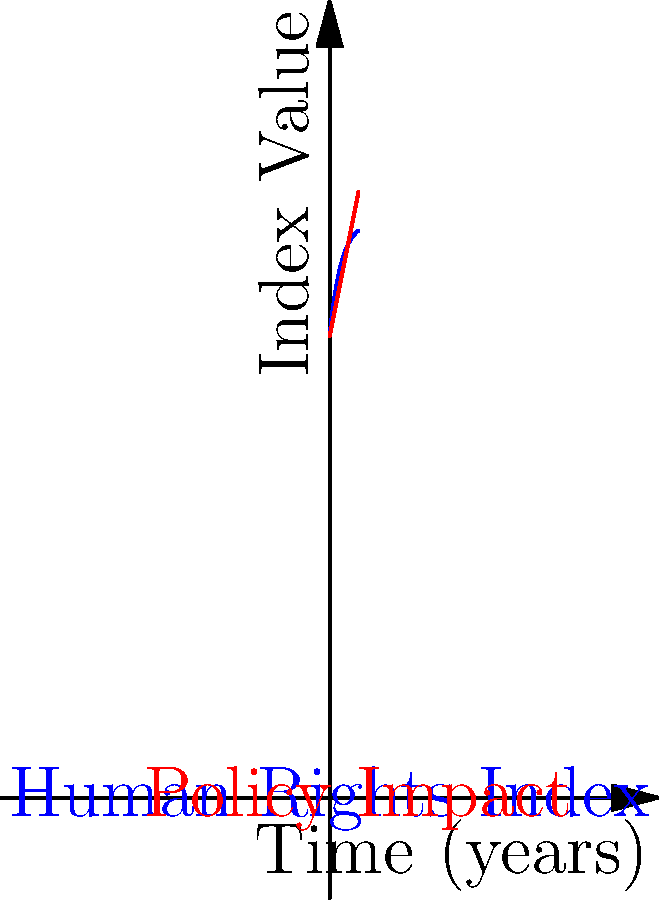Consider the graph above, where the blue curve represents the Human Rights Index (HRI) over time, given by the function $f(t) = 100 - 20e^{-0.5t}$, and the red line represents the cumulative impact of policy changes on human rights, given by $g(t) = 80 + 5t$. Calculate the total difference between the Human Rights Index and the policy impact over the first 5 years, represented by the area between the two curves from $t=0$ to $t=5$.

$$\int_0^5 [f(t) - g(t)] dt$$ To solve this integral calculus problem, we'll follow these steps:

1) First, let's set up the integral:
   $$\int_0^5 [(100 - 20e^{-0.5t}) - (80 + 5t)] dt$$

2) Simplify the integrand:
   $$\int_0^5 [20 - 20e^{-0.5t} - 5t] dt$$

3) Now, we can split this into three integrals:
   $$\int_0^5 20 dt - \int_0^5 20e^{-0.5t} dt - \int_0^5 5t dt$$

4) Solve each integral:
   a) $\int_0^5 20 dt = 20t |_0^5 = 100$
   
   b) $\int_0^5 20e^{-0.5t} dt = -40e^{-0.5t} |_0^5 = -40(e^{-2.5} - 1)$
   
   c) $\int_0^5 5t dt = \frac{5t^2}{2} |_0^5 = \frac{125}{2}$

5) Combine the results:
   $100 - [-40(e^{-2.5} - 1)] - \frac{125}{2}$

6) Simplify:
   $100 + 40(e^{-2.5} - 1) - 62.5$
   $= 37.5 + 40(e^{-2.5} - 1)$
   $≈ 22.95$ (rounded to two decimal places)

This result represents the total difference between the Human Rights Index and the policy impact over the first 5 years, measured in index-years.
Answer: 22.95 index-years 